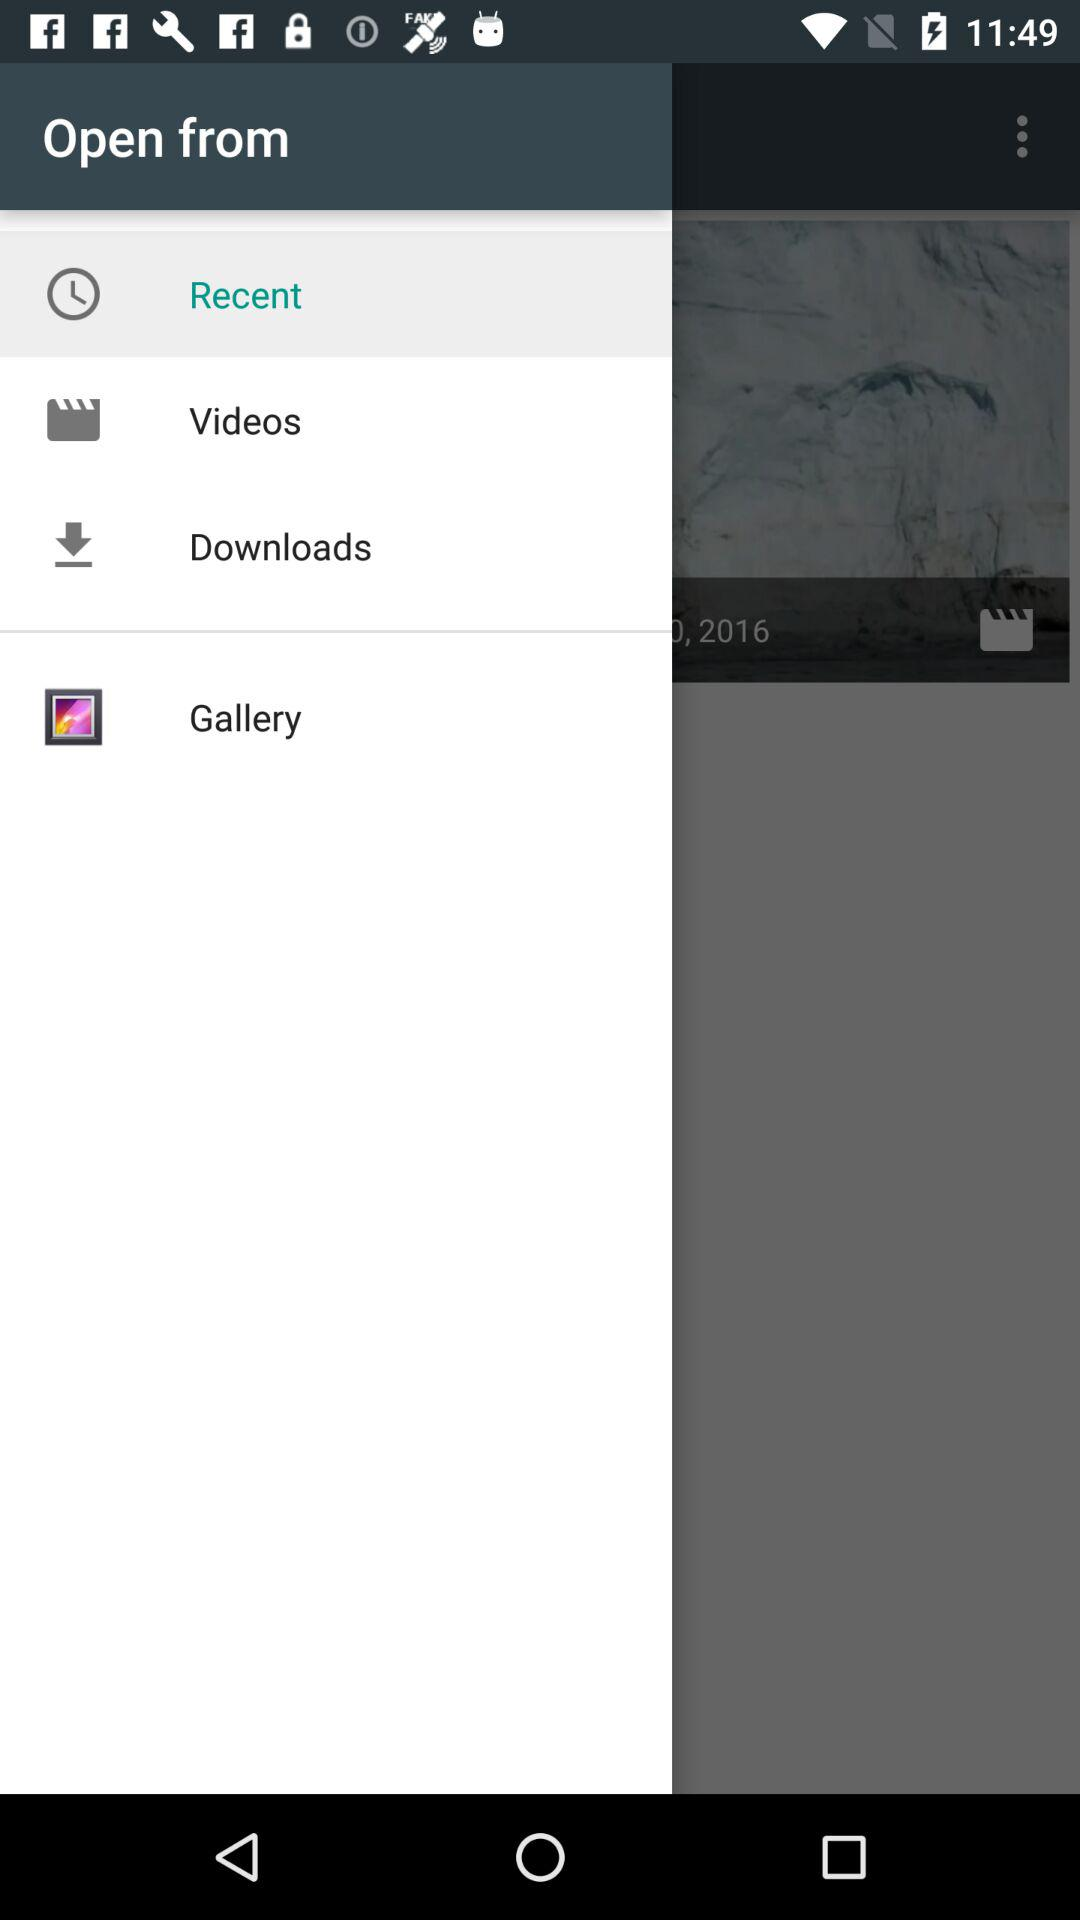Which option has been selected? The selected option is "Recent". 